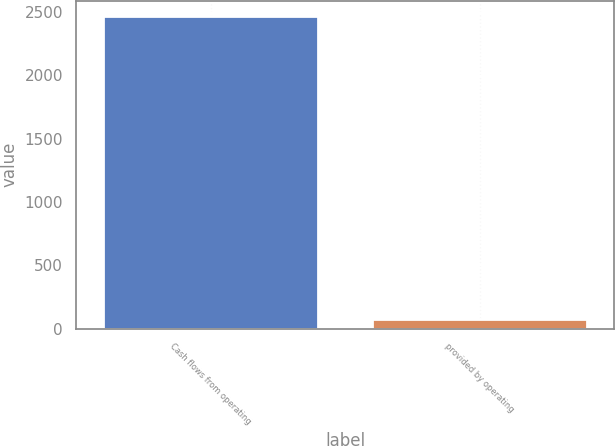Convert chart. <chart><loc_0><loc_0><loc_500><loc_500><bar_chart><fcel>Cash flows from operating<fcel>provided by operating<nl><fcel>2464<fcel>77<nl></chart> 